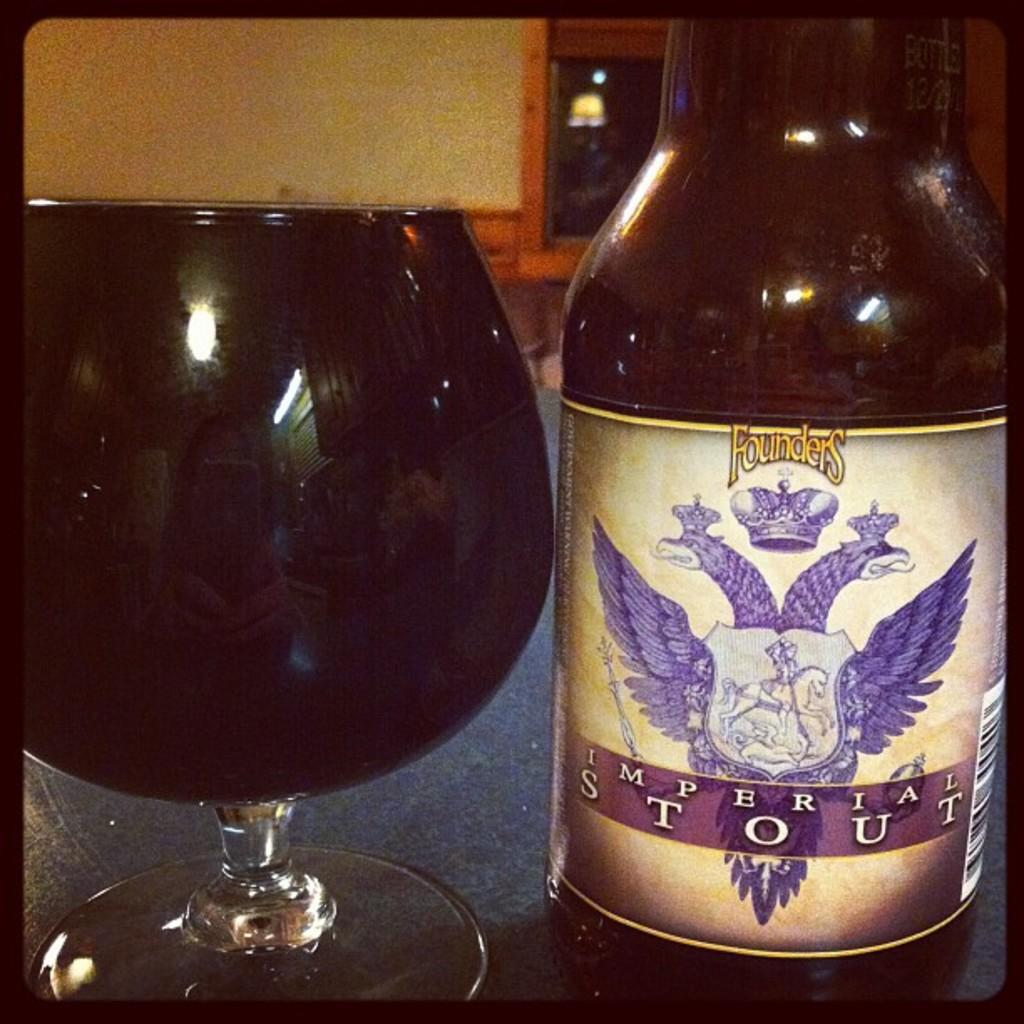<image>
Offer a succinct explanation of the picture presented. A bottle of Founder's Imperial Stout with a 2 headed purple beast on the label. 